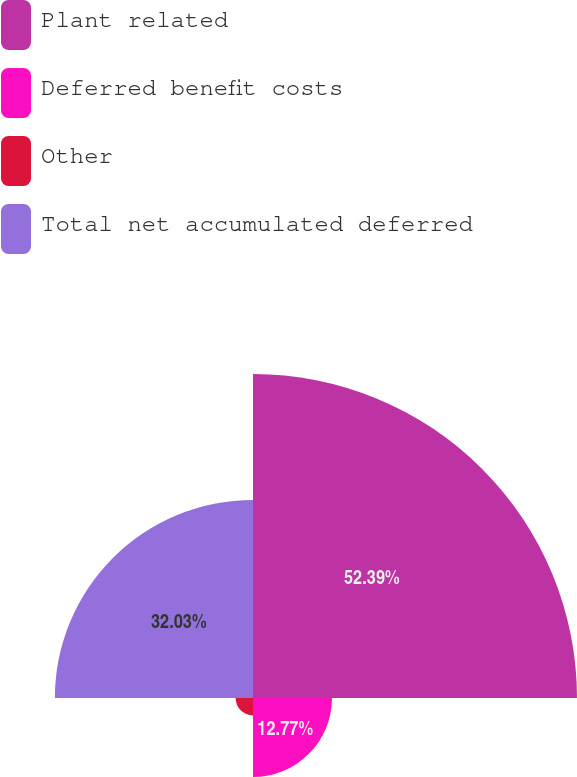Convert chart to OTSL. <chart><loc_0><loc_0><loc_500><loc_500><pie_chart><fcel>Plant related<fcel>Deferred benefit costs<fcel>Other<fcel>Total net accumulated deferred<nl><fcel>52.38%<fcel>12.77%<fcel>2.81%<fcel>32.03%<nl></chart> 